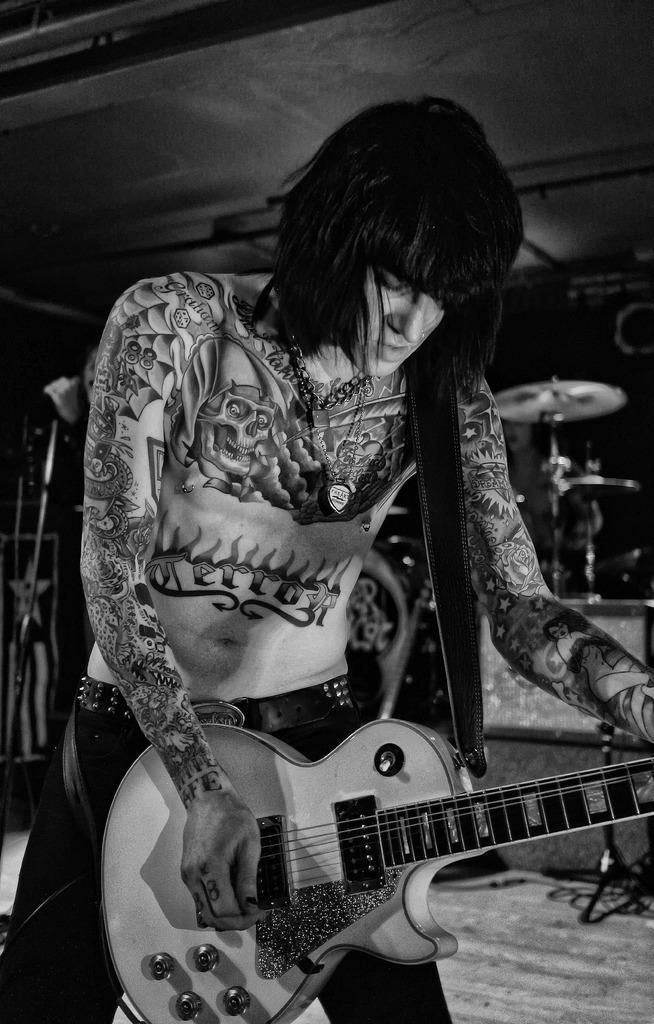Please provide a concise description of this image. There is a person. He is standing. His body has so many tattoos. He is holding a guitar. We can see in the background there is a so many musical instruments. 